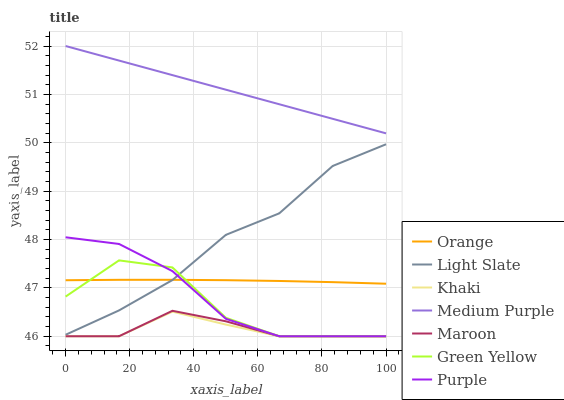Does Khaki have the minimum area under the curve?
Answer yes or no. Yes. Does Light Slate have the minimum area under the curve?
Answer yes or no. No. Does Light Slate have the maximum area under the curve?
Answer yes or no. No. Is Medium Purple the smoothest?
Answer yes or no. Yes. Is Green Yellow the roughest?
Answer yes or no. Yes. Is Light Slate the smoothest?
Answer yes or no. No. Is Light Slate the roughest?
Answer yes or no. No. Does Light Slate have the lowest value?
Answer yes or no. No. Does Light Slate have the highest value?
Answer yes or no. No. Is Khaki less than Medium Purple?
Answer yes or no. Yes. Is Medium Purple greater than Maroon?
Answer yes or no. Yes. Does Khaki intersect Medium Purple?
Answer yes or no. No. 